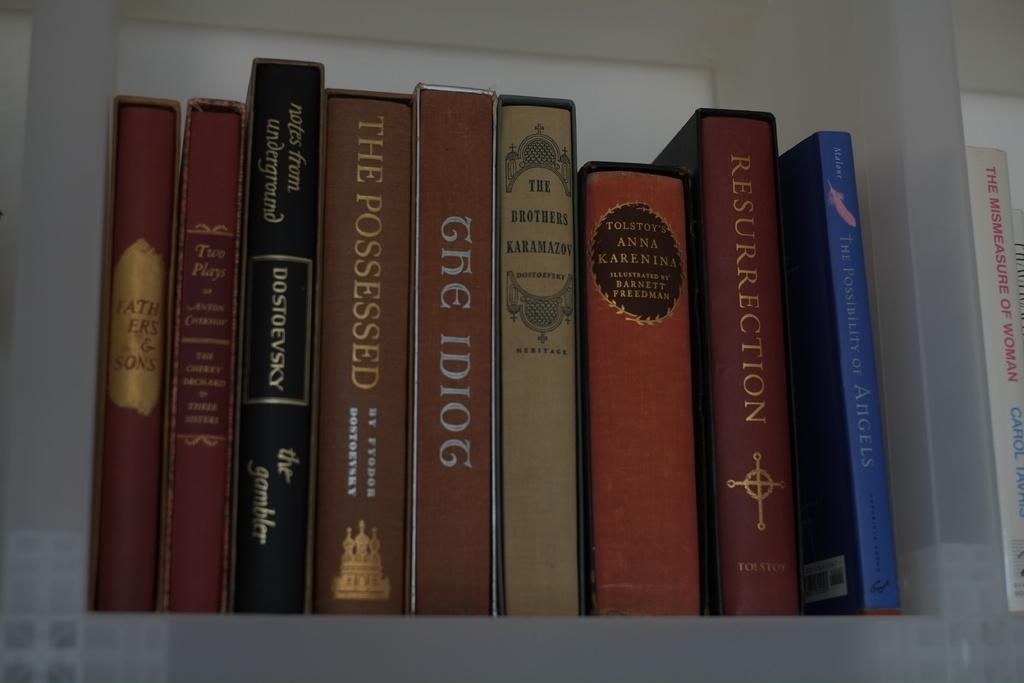Provide a one-sentence caption for the provided image. Books are lined up on a shelf, including The Possessed. 